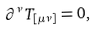Convert formula to latex. <formula><loc_0><loc_0><loc_500><loc_500>\partial ^ { \nu } T _ { [ \mu \nu ] } = 0 ,</formula> 